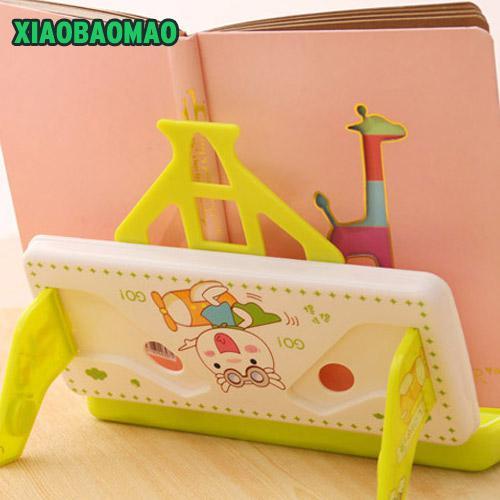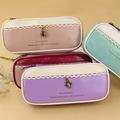The first image is the image on the left, the second image is the image on the right. Examine the images to the left and right. Is the description "The right image contains four different colored small bags." accurate? Answer yes or no. Yes. The first image is the image on the left, the second image is the image on the right. Examine the images to the left and right. Is the description "There are four cases in the image on the left." accurate? Answer yes or no. No. 